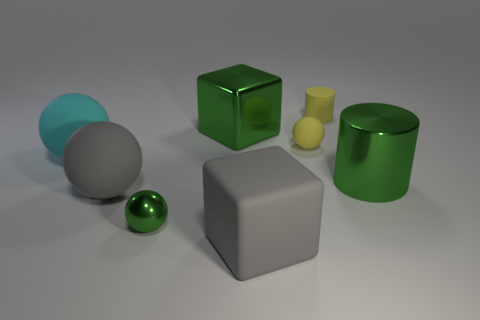How many matte objects are either small balls or cyan things?
Provide a succinct answer. 2. Does the metallic cylinder have the same color as the small shiny sphere?
Offer a very short reply. Yes. How many things are large rubber things or large gray rubber things to the right of the green sphere?
Your answer should be compact. 3. Do the gray matte object that is to the left of the gray rubber cube and the yellow sphere have the same size?
Your answer should be very brief. No. How many other objects are the same shape as the cyan object?
Your answer should be very brief. 3. What number of blue things are either matte things or tiny rubber cubes?
Your answer should be very brief. 0. There is a tiny metallic sphere that is in front of the rubber cylinder; does it have the same color as the large shiny cylinder?
Your answer should be very brief. Yes. There is a cyan object that is made of the same material as the large gray cube; what is its shape?
Ensure brevity in your answer.  Sphere. What color is the rubber thing that is both in front of the big shiny cylinder and to the right of the tiny metallic thing?
Provide a succinct answer. Gray. How big is the yellow matte thing that is behind the small matte thing that is in front of the yellow cylinder?
Your response must be concise. Small. 